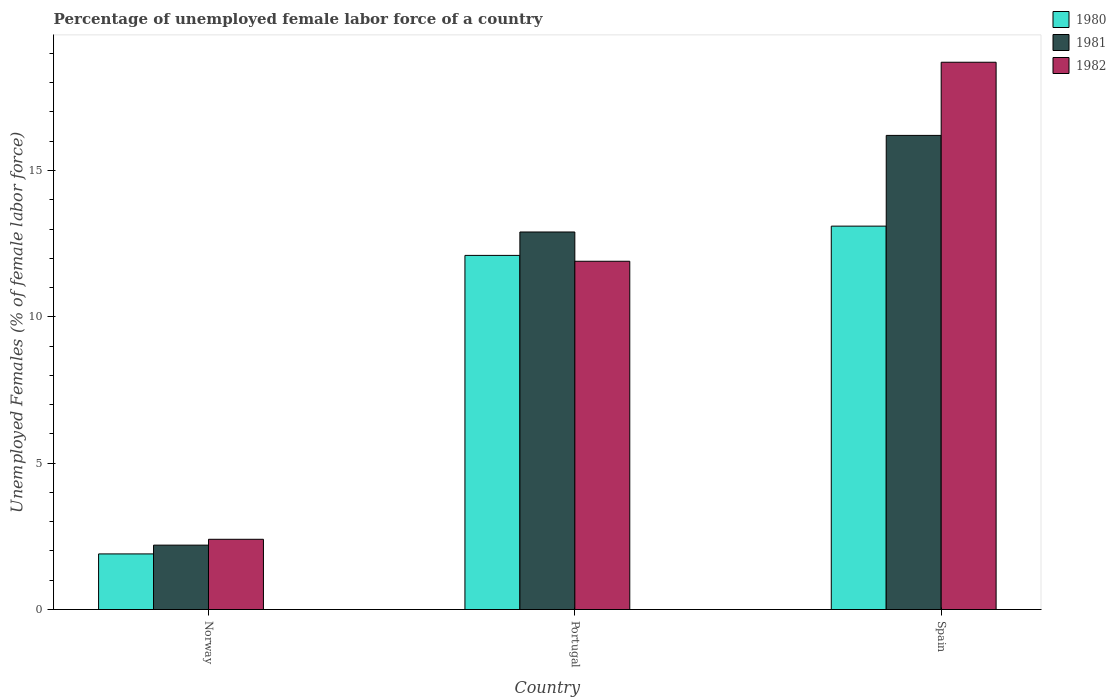Are the number of bars per tick equal to the number of legend labels?
Offer a very short reply. Yes. Are the number of bars on each tick of the X-axis equal?
Give a very brief answer. Yes. How many bars are there on the 2nd tick from the right?
Make the answer very short. 3. What is the label of the 2nd group of bars from the left?
Keep it short and to the point. Portugal. In how many cases, is the number of bars for a given country not equal to the number of legend labels?
Your response must be concise. 0. What is the percentage of unemployed female labor force in 1980 in Norway?
Keep it short and to the point. 1.9. Across all countries, what is the maximum percentage of unemployed female labor force in 1981?
Your response must be concise. 16.2. Across all countries, what is the minimum percentage of unemployed female labor force in 1980?
Keep it short and to the point. 1.9. In which country was the percentage of unemployed female labor force in 1980 maximum?
Give a very brief answer. Spain. In which country was the percentage of unemployed female labor force in 1981 minimum?
Provide a short and direct response. Norway. What is the total percentage of unemployed female labor force in 1982 in the graph?
Offer a terse response. 33. What is the difference between the percentage of unemployed female labor force in 1981 in Norway and that in Portugal?
Ensure brevity in your answer.  -10.7. What is the difference between the percentage of unemployed female labor force in 1981 in Norway and the percentage of unemployed female labor force in 1982 in Portugal?
Make the answer very short. -9.7. What is the average percentage of unemployed female labor force in 1980 per country?
Give a very brief answer. 9.03. What is the difference between the percentage of unemployed female labor force of/in 1980 and percentage of unemployed female labor force of/in 1981 in Norway?
Provide a succinct answer. -0.3. What is the ratio of the percentage of unemployed female labor force in 1982 in Portugal to that in Spain?
Provide a succinct answer. 0.64. Is the difference between the percentage of unemployed female labor force in 1980 in Portugal and Spain greater than the difference between the percentage of unemployed female labor force in 1981 in Portugal and Spain?
Your response must be concise. Yes. What is the difference between the highest and the second highest percentage of unemployed female labor force in 1982?
Keep it short and to the point. 6.8. What is the difference between the highest and the lowest percentage of unemployed female labor force in 1982?
Ensure brevity in your answer.  16.3. In how many countries, is the percentage of unemployed female labor force in 1982 greater than the average percentage of unemployed female labor force in 1982 taken over all countries?
Your response must be concise. 2. What does the 1st bar from the left in Spain represents?
Provide a succinct answer. 1980. What does the 3rd bar from the right in Portugal represents?
Your answer should be very brief. 1980. How many bars are there?
Make the answer very short. 9. Are all the bars in the graph horizontal?
Your answer should be compact. No. Are the values on the major ticks of Y-axis written in scientific E-notation?
Offer a very short reply. No. Where does the legend appear in the graph?
Provide a succinct answer. Top right. How are the legend labels stacked?
Make the answer very short. Vertical. What is the title of the graph?
Give a very brief answer. Percentage of unemployed female labor force of a country. What is the label or title of the Y-axis?
Provide a short and direct response. Unemployed Females (% of female labor force). What is the Unemployed Females (% of female labor force) of 1980 in Norway?
Provide a succinct answer. 1.9. What is the Unemployed Females (% of female labor force) in 1981 in Norway?
Offer a very short reply. 2.2. What is the Unemployed Females (% of female labor force) of 1982 in Norway?
Make the answer very short. 2.4. What is the Unemployed Females (% of female labor force) in 1980 in Portugal?
Your answer should be compact. 12.1. What is the Unemployed Females (% of female labor force) of 1981 in Portugal?
Offer a terse response. 12.9. What is the Unemployed Females (% of female labor force) in 1982 in Portugal?
Provide a short and direct response. 11.9. What is the Unemployed Females (% of female labor force) of 1980 in Spain?
Offer a terse response. 13.1. What is the Unemployed Females (% of female labor force) in 1981 in Spain?
Give a very brief answer. 16.2. What is the Unemployed Females (% of female labor force) in 1982 in Spain?
Your response must be concise. 18.7. Across all countries, what is the maximum Unemployed Females (% of female labor force) of 1980?
Provide a short and direct response. 13.1. Across all countries, what is the maximum Unemployed Females (% of female labor force) of 1981?
Offer a very short reply. 16.2. Across all countries, what is the maximum Unemployed Females (% of female labor force) of 1982?
Your answer should be compact. 18.7. Across all countries, what is the minimum Unemployed Females (% of female labor force) of 1980?
Your answer should be very brief. 1.9. Across all countries, what is the minimum Unemployed Females (% of female labor force) of 1981?
Offer a very short reply. 2.2. Across all countries, what is the minimum Unemployed Females (% of female labor force) of 1982?
Provide a succinct answer. 2.4. What is the total Unemployed Females (% of female labor force) of 1980 in the graph?
Offer a terse response. 27.1. What is the total Unemployed Females (% of female labor force) in 1981 in the graph?
Keep it short and to the point. 31.3. What is the total Unemployed Females (% of female labor force) of 1982 in the graph?
Offer a terse response. 33. What is the difference between the Unemployed Females (% of female labor force) of 1981 in Norway and that in Portugal?
Provide a succinct answer. -10.7. What is the difference between the Unemployed Females (% of female labor force) of 1982 in Norway and that in Portugal?
Provide a short and direct response. -9.5. What is the difference between the Unemployed Females (% of female labor force) in 1980 in Norway and that in Spain?
Provide a short and direct response. -11.2. What is the difference between the Unemployed Females (% of female labor force) of 1981 in Norway and that in Spain?
Ensure brevity in your answer.  -14. What is the difference between the Unemployed Females (% of female labor force) in 1982 in Norway and that in Spain?
Your response must be concise. -16.3. What is the difference between the Unemployed Females (% of female labor force) of 1980 in Norway and the Unemployed Females (% of female labor force) of 1981 in Portugal?
Give a very brief answer. -11. What is the difference between the Unemployed Females (% of female labor force) in 1980 in Norway and the Unemployed Females (% of female labor force) in 1981 in Spain?
Offer a very short reply. -14.3. What is the difference between the Unemployed Females (% of female labor force) of 1980 in Norway and the Unemployed Females (% of female labor force) of 1982 in Spain?
Your answer should be compact. -16.8. What is the difference between the Unemployed Females (% of female labor force) of 1981 in Norway and the Unemployed Females (% of female labor force) of 1982 in Spain?
Your response must be concise. -16.5. What is the difference between the Unemployed Females (% of female labor force) of 1980 in Portugal and the Unemployed Females (% of female labor force) of 1982 in Spain?
Your answer should be very brief. -6.6. What is the average Unemployed Females (% of female labor force) of 1980 per country?
Keep it short and to the point. 9.03. What is the average Unemployed Females (% of female labor force) in 1981 per country?
Your response must be concise. 10.43. What is the difference between the Unemployed Females (% of female labor force) of 1980 and Unemployed Females (% of female labor force) of 1982 in Norway?
Your response must be concise. -0.5. What is the difference between the Unemployed Females (% of female labor force) in 1981 and Unemployed Females (% of female labor force) in 1982 in Norway?
Your answer should be compact. -0.2. What is the difference between the Unemployed Females (% of female labor force) of 1980 and Unemployed Females (% of female labor force) of 1982 in Portugal?
Ensure brevity in your answer.  0.2. What is the ratio of the Unemployed Females (% of female labor force) in 1980 in Norway to that in Portugal?
Your answer should be very brief. 0.16. What is the ratio of the Unemployed Females (% of female labor force) in 1981 in Norway to that in Portugal?
Your response must be concise. 0.17. What is the ratio of the Unemployed Females (% of female labor force) of 1982 in Norway to that in Portugal?
Provide a succinct answer. 0.2. What is the ratio of the Unemployed Females (% of female labor force) in 1980 in Norway to that in Spain?
Provide a short and direct response. 0.14. What is the ratio of the Unemployed Females (% of female labor force) in 1981 in Norway to that in Spain?
Your answer should be very brief. 0.14. What is the ratio of the Unemployed Females (% of female labor force) in 1982 in Norway to that in Spain?
Provide a short and direct response. 0.13. What is the ratio of the Unemployed Females (% of female labor force) in 1980 in Portugal to that in Spain?
Your answer should be compact. 0.92. What is the ratio of the Unemployed Females (% of female labor force) of 1981 in Portugal to that in Spain?
Your answer should be compact. 0.8. What is the ratio of the Unemployed Females (% of female labor force) in 1982 in Portugal to that in Spain?
Provide a short and direct response. 0.64. What is the difference between the highest and the second highest Unemployed Females (% of female labor force) in 1982?
Ensure brevity in your answer.  6.8. What is the difference between the highest and the lowest Unemployed Females (% of female labor force) of 1980?
Ensure brevity in your answer.  11.2. What is the difference between the highest and the lowest Unemployed Females (% of female labor force) in 1981?
Provide a succinct answer. 14. What is the difference between the highest and the lowest Unemployed Females (% of female labor force) in 1982?
Offer a terse response. 16.3. 